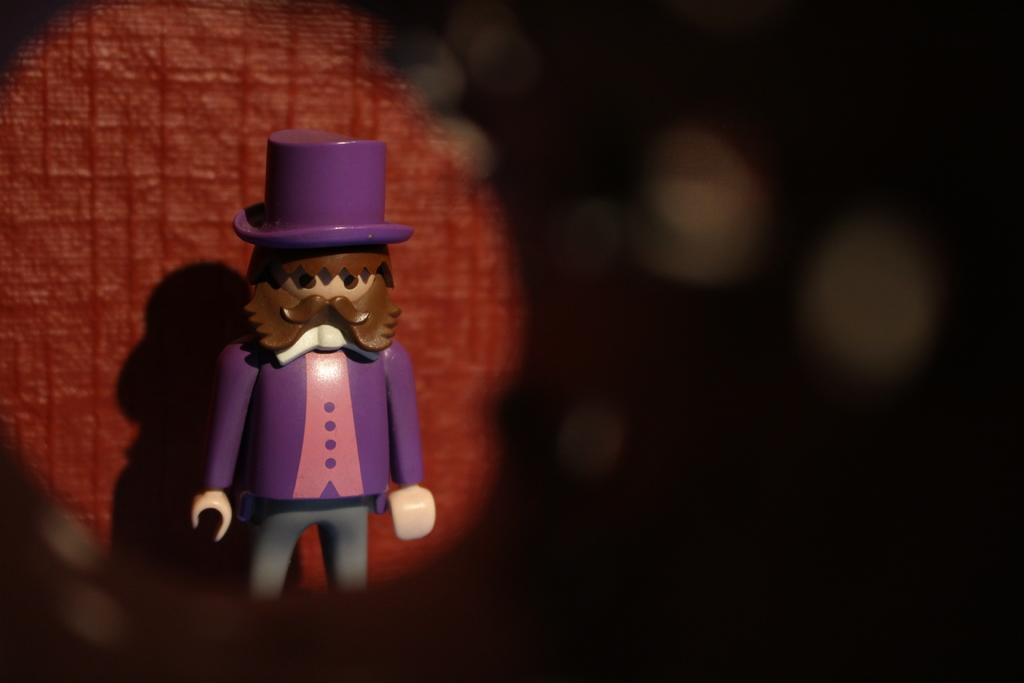What object can be seen in the image? There is a toy in the image. What can be seen in the distance behind the toy? There is a wall in the background of the image. Can you describe the appearance of the wall? Part of the wall is blurry. Can you tell me how many basketballs are on the wall in the image? There are no basketballs present in the image; it features a toy and a wall. Is there a son playing with the toy in the image? There is no information about a son or anyone playing with the toy in the image. 